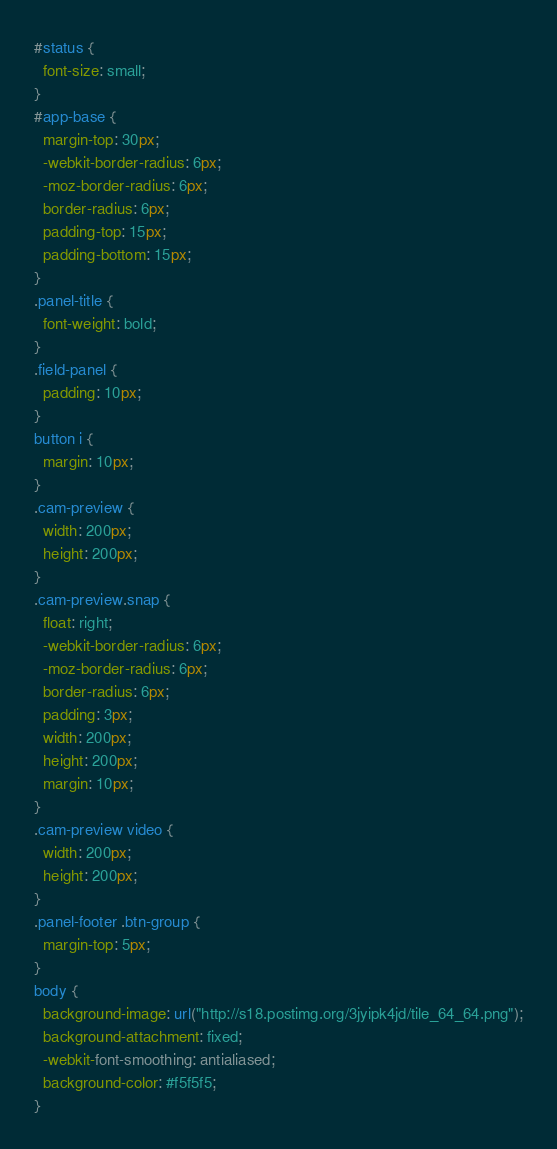<code> <loc_0><loc_0><loc_500><loc_500><_CSS_>#status {
  font-size: small;
}
#app-base {
  margin-top: 30px;
  -webkit-border-radius: 6px;
  -moz-border-radius: 6px;
  border-radius: 6px;
  padding-top: 15px;
  padding-bottom: 15px;
}
.panel-title {
  font-weight: bold;
}
.field-panel {
  padding: 10px;
}
button i {
  margin: 10px;
}
.cam-preview {
  width: 200px;
  height: 200px;
}
.cam-preview.snap {
  float: right;
  -webkit-border-radius: 6px;
  -moz-border-radius: 6px;
  border-radius: 6px;
  padding: 3px;
  width: 200px;
  height: 200px;
  margin: 10px;
}
.cam-preview video {
  width: 200px;
  height: 200px;
}
.panel-footer .btn-group {
  margin-top: 5px;
}
body {
  background-image: url("http://s18.postimg.org/3jyipk4jd/tile_64_64.png");
  background-attachment: fixed;
  -webkit-font-smoothing: antialiased;
  background-color: #f5f5f5;
}
</code> 